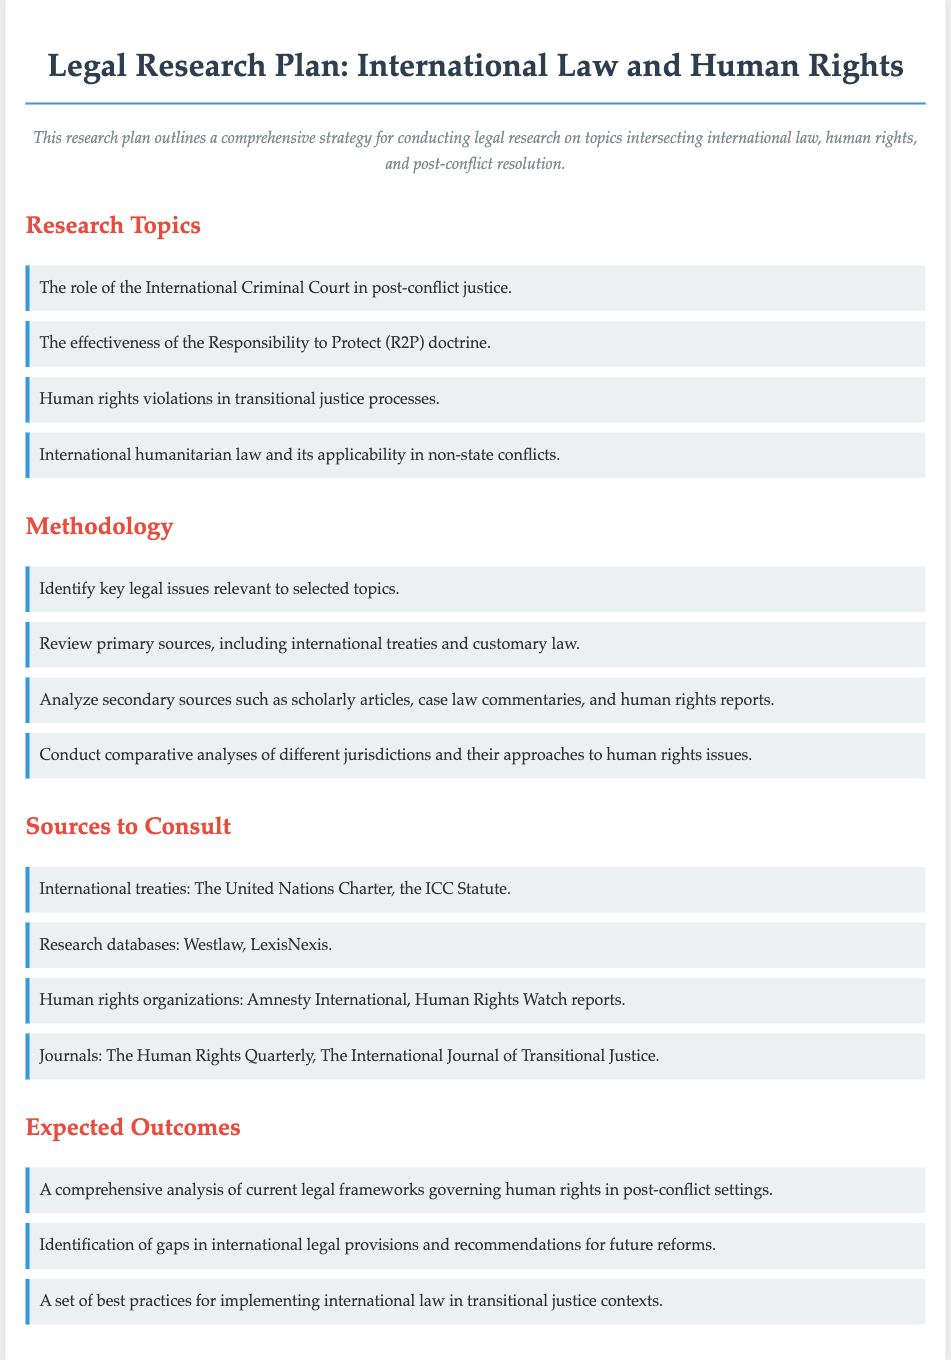What are the four research topics listed? The document outlines four specific research topics related to international law and human rights, providing a focus for the legal research plan.
Answer: The role of the International Criminal Court in post-conflict justice, the effectiveness of the Responsibility to Protect (R2P) doctrine, human rights violations in transitional justice processes, international humanitarian law and its applicability in non-state conflicts What is one method suggested for conducting this research? The document lists a methodology that includes several methods relevant to the proposed research strategy.
Answer: Review primary sources, including international treaties and customary law Which organizations' reports are recommended as sources? The document suggests consulting reports from specific human rights organizations to inform research.
Answer: Amnesty International, Human Rights Watch reports What is one expected outcome of this research plan? The document outlines several anticipated results that the research process aims to achieve within the scope of international law and human rights.
Answer: A comprehensive analysis of current legal frameworks governing human rights in post-conflict settings What databases are mentioned for legal research? The document provides a list of databases to assist in conducting thorough legal research on the topic.
Answer: Westlaw, LexisNexis 